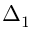<formula> <loc_0><loc_0><loc_500><loc_500>\Delta _ { 1 }</formula> 